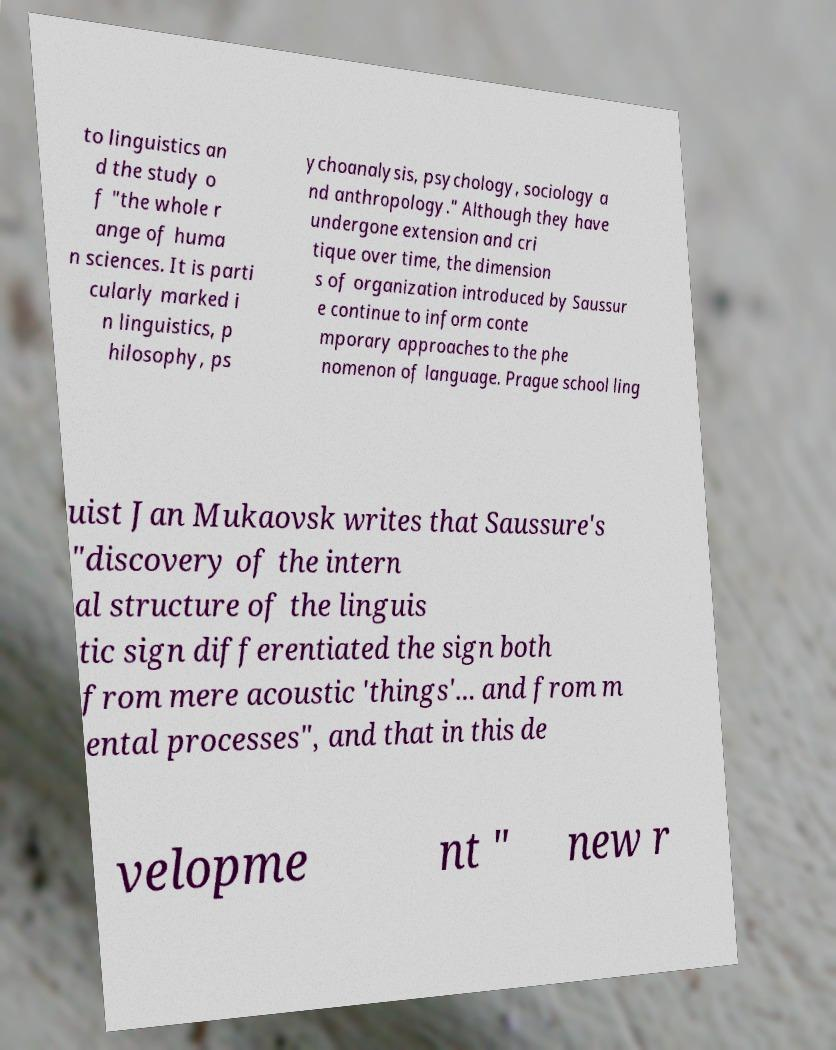I need the written content from this picture converted into text. Can you do that? to linguistics an d the study o f "the whole r ange of huma n sciences. It is parti cularly marked i n linguistics, p hilosophy, ps ychoanalysis, psychology, sociology a nd anthropology." Although they have undergone extension and cri tique over time, the dimension s of organization introduced by Saussur e continue to inform conte mporary approaches to the phe nomenon of language. Prague school ling uist Jan Mukaovsk writes that Saussure's "discovery of the intern al structure of the linguis tic sign differentiated the sign both from mere acoustic 'things'... and from m ental processes", and that in this de velopme nt " new r 